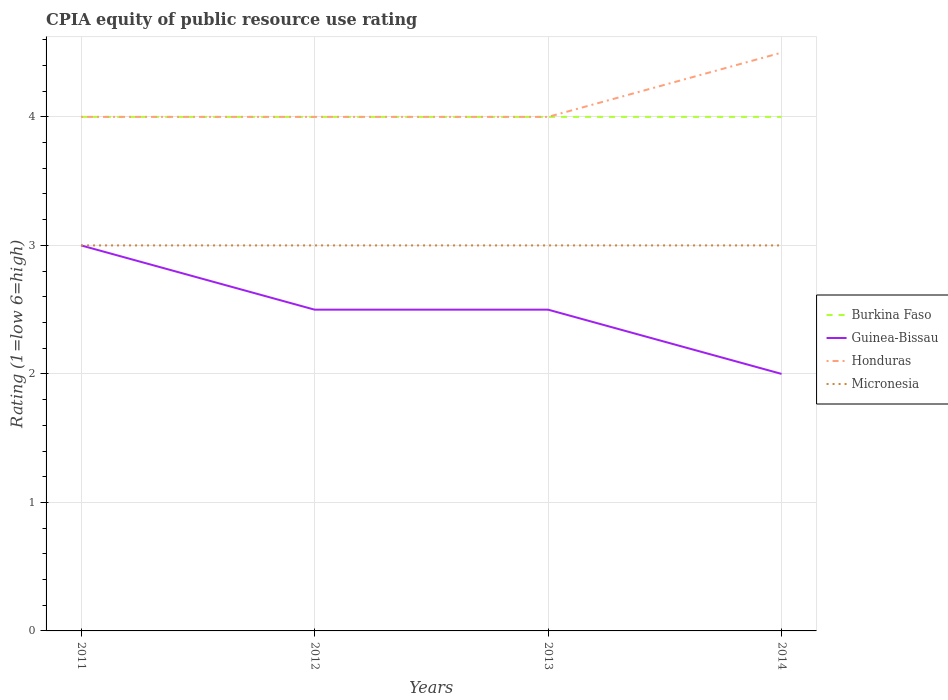How many different coloured lines are there?
Ensure brevity in your answer.  4. Does the line corresponding to Honduras intersect with the line corresponding to Guinea-Bissau?
Offer a very short reply. No. Across all years, what is the maximum CPIA rating in Honduras?
Keep it short and to the point. 4. What is the total CPIA rating in Micronesia in the graph?
Make the answer very short. 0. What is the difference between the highest and the second highest CPIA rating in Guinea-Bissau?
Ensure brevity in your answer.  1. What is the difference between the highest and the lowest CPIA rating in Honduras?
Your answer should be very brief. 1. How many lines are there?
Keep it short and to the point. 4. What is the difference between two consecutive major ticks on the Y-axis?
Your answer should be compact. 1. Does the graph contain any zero values?
Offer a terse response. No. Does the graph contain grids?
Your answer should be compact. Yes. Where does the legend appear in the graph?
Your answer should be very brief. Center right. What is the title of the graph?
Provide a short and direct response. CPIA equity of public resource use rating. Does "Netherlands" appear as one of the legend labels in the graph?
Give a very brief answer. No. What is the label or title of the X-axis?
Provide a succinct answer. Years. What is the label or title of the Y-axis?
Your answer should be very brief. Rating (1=low 6=high). What is the Rating (1=low 6=high) of Burkina Faso in 2011?
Offer a terse response. 4. What is the Rating (1=low 6=high) in Burkina Faso in 2012?
Provide a short and direct response. 4. What is the Rating (1=low 6=high) of Honduras in 2012?
Your answer should be compact. 4. What is the Rating (1=low 6=high) of Guinea-Bissau in 2013?
Ensure brevity in your answer.  2.5. What is the Rating (1=low 6=high) in Micronesia in 2013?
Give a very brief answer. 3. What is the Rating (1=low 6=high) of Guinea-Bissau in 2014?
Make the answer very short. 2. What is the Rating (1=low 6=high) in Honduras in 2014?
Keep it short and to the point. 4.5. Across all years, what is the minimum Rating (1=low 6=high) of Burkina Faso?
Offer a terse response. 4. What is the total Rating (1=low 6=high) of Burkina Faso in the graph?
Offer a terse response. 16. What is the difference between the Rating (1=low 6=high) in Burkina Faso in 2011 and that in 2012?
Your answer should be very brief. 0. What is the difference between the Rating (1=low 6=high) in Micronesia in 2011 and that in 2012?
Offer a very short reply. 0. What is the difference between the Rating (1=low 6=high) in Burkina Faso in 2011 and that in 2013?
Keep it short and to the point. 0. What is the difference between the Rating (1=low 6=high) of Guinea-Bissau in 2011 and that in 2013?
Offer a terse response. 0.5. What is the difference between the Rating (1=low 6=high) in Micronesia in 2011 and that in 2013?
Provide a short and direct response. 0. What is the difference between the Rating (1=low 6=high) of Burkina Faso in 2011 and that in 2014?
Offer a very short reply. 0. What is the difference between the Rating (1=low 6=high) in Honduras in 2011 and that in 2014?
Your answer should be very brief. -0.5. What is the difference between the Rating (1=low 6=high) in Burkina Faso in 2012 and that in 2013?
Offer a terse response. 0. What is the difference between the Rating (1=low 6=high) of Guinea-Bissau in 2012 and that in 2013?
Your answer should be compact. 0. What is the difference between the Rating (1=low 6=high) of Micronesia in 2012 and that in 2013?
Give a very brief answer. 0. What is the difference between the Rating (1=low 6=high) in Burkina Faso in 2012 and that in 2014?
Your response must be concise. 0. What is the difference between the Rating (1=low 6=high) of Honduras in 2012 and that in 2014?
Your response must be concise. -0.5. What is the difference between the Rating (1=low 6=high) in Micronesia in 2012 and that in 2014?
Your response must be concise. 0. What is the difference between the Rating (1=low 6=high) in Burkina Faso in 2011 and the Rating (1=low 6=high) in Honduras in 2012?
Offer a terse response. 0. What is the difference between the Rating (1=low 6=high) in Burkina Faso in 2011 and the Rating (1=low 6=high) in Micronesia in 2012?
Your response must be concise. 1. What is the difference between the Rating (1=low 6=high) in Guinea-Bissau in 2011 and the Rating (1=low 6=high) in Honduras in 2012?
Provide a short and direct response. -1. What is the difference between the Rating (1=low 6=high) in Guinea-Bissau in 2011 and the Rating (1=low 6=high) in Micronesia in 2012?
Make the answer very short. 0. What is the difference between the Rating (1=low 6=high) in Honduras in 2011 and the Rating (1=low 6=high) in Micronesia in 2012?
Your answer should be very brief. 1. What is the difference between the Rating (1=low 6=high) of Honduras in 2011 and the Rating (1=low 6=high) of Micronesia in 2013?
Give a very brief answer. 1. What is the difference between the Rating (1=low 6=high) in Burkina Faso in 2011 and the Rating (1=low 6=high) in Guinea-Bissau in 2014?
Keep it short and to the point. 2. What is the difference between the Rating (1=low 6=high) of Guinea-Bissau in 2011 and the Rating (1=low 6=high) of Micronesia in 2014?
Offer a terse response. 0. What is the difference between the Rating (1=low 6=high) of Honduras in 2011 and the Rating (1=low 6=high) of Micronesia in 2014?
Your answer should be compact. 1. What is the difference between the Rating (1=low 6=high) of Burkina Faso in 2012 and the Rating (1=low 6=high) of Guinea-Bissau in 2013?
Your answer should be very brief. 1.5. What is the difference between the Rating (1=low 6=high) in Burkina Faso in 2012 and the Rating (1=low 6=high) in Micronesia in 2013?
Your answer should be compact. 1. What is the difference between the Rating (1=low 6=high) of Guinea-Bissau in 2012 and the Rating (1=low 6=high) of Honduras in 2013?
Offer a very short reply. -1.5. What is the difference between the Rating (1=low 6=high) of Guinea-Bissau in 2012 and the Rating (1=low 6=high) of Micronesia in 2014?
Keep it short and to the point. -0.5. What is the difference between the Rating (1=low 6=high) of Honduras in 2012 and the Rating (1=low 6=high) of Micronesia in 2014?
Offer a very short reply. 1. What is the difference between the Rating (1=low 6=high) in Burkina Faso in 2013 and the Rating (1=low 6=high) in Honduras in 2014?
Provide a succinct answer. -0.5. What is the difference between the Rating (1=low 6=high) of Burkina Faso in 2013 and the Rating (1=low 6=high) of Micronesia in 2014?
Offer a terse response. 1. What is the difference between the Rating (1=low 6=high) in Guinea-Bissau in 2013 and the Rating (1=low 6=high) in Micronesia in 2014?
Ensure brevity in your answer.  -0.5. What is the difference between the Rating (1=low 6=high) of Honduras in 2013 and the Rating (1=low 6=high) of Micronesia in 2014?
Offer a very short reply. 1. What is the average Rating (1=low 6=high) of Honduras per year?
Offer a very short reply. 4.12. In the year 2011, what is the difference between the Rating (1=low 6=high) in Burkina Faso and Rating (1=low 6=high) in Guinea-Bissau?
Ensure brevity in your answer.  1. In the year 2011, what is the difference between the Rating (1=low 6=high) in Burkina Faso and Rating (1=low 6=high) in Micronesia?
Your answer should be very brief. 1. In the year 2011, what is the difference between the Rating (1=low 6=high) of Guinea-Bissau and Rating (1=low 6=high) of Honduras?
Give a very brief answer. -1. In the year 2011, what is the difference between the Rating (1=low 6=high) in Guinea-Bissau and Rating (1=low 6=high) in Micronesia?
Give a very brief answer. 0. In the year 2011, what is the difference between the Rating (1=low 6=high) of Honduras and Rating (1=low 6=high) of Micronesia?
Offer a very short reply. 1. In the year 2012, what is the difference between the Rating (1=low 6=high) of Burkina Faso and Rating (1=low 6=high) of Guinea-Bissau?
Offer a terse response. 1.5. In the year 2012, what is the difference between the Rating (1=low 6=high) of Burkina Faso and Rating (1=low 6=high) of Honduras?
Your answer should be compact. 0. In the year 2012, what is the difference between the Rating (1=low 6=high) of Burkina Faso and Rating (1=low 6=high) of Micronesia?
Make the answer very short. 1. In the year 2012, what is the difference between the Rating (1=low 6=high) of Guinea-Bissau and Rating (1=low 6=high) of Honduras?
Provide a succinct answer. -1.5. In the year 2012, what is the difference between the Rating (1=low 6=high) of Honduras and Rating (1=low 6=high) of Micronesia?
Keep it short and to the point. 1. In the year 2013, what is the difference between the Rating (1=low 6=high) in Burkina Faso and Rating (1=low 6=high) in Micronesia?
Give a very brief answer. 1. In the year 2013, what is the difference between the Rating (1=low 6=high) in Guinea-Bissau and Rating (1=low 6=high) in Honduras?
Offer a very short reply. -1.5. In the year 2013, what is the difference between the Rating (1=low 6=high) of Honduras and Rating (1=low 6=high) of Micronesia?
Make the answer very short. 1. In the year 2014, what is the difference between the Rating (1=low 6=high) in Burkina Faso and Rating (1=low 6=high) in Micronesia?
Make the answer very short. 1. In the year 2014, what is the difference between the Rating (1=low 6=high) of Honduras and Rating (1=low 6=high) of Micronesia?
Offer a very short reply. 1.5. What is the ratio of the Rating (1=low 6=high) in Guinea-Bissau in 2011 to that in 2012?
Ensure brevity in your answer.  1.2. What is the ratio of the Rating (1=low 6=high) in Micronesia in 2011 to that in 2012?
Your answer should be very brief. 1. What is the ratio of the Rating (1=low 6=high) of Guinea-Bissau in 2011 to that in 2013?
Give a very brief answer. 1.2. What is the ratio of the Rating (1=low 6=high) in Honduras in 2011 to that in 2013?
Give a very brief answer. 1. What is the ratio of the Rating (1=low 6=high) in Micronesia in 2011 to that in 2013?
Offer a terse response. 1. What is the ratio of the Rating (1=low 6=high) of Burkina Faso in 2011 to that in 2014?
Your response must be concise. 1. What is the ratio of the Rating (1=low 6=high) in Micronesia in 2011 to that in 2014?
Keep it short and to the point. 1. What is the ratio of the Rating (1=low 6=high) in Burkina Faso in 2012 to that in 2013?
Provide a short and direct response. 1. What is the ratio of the Rating (1=low 6=high) of Guinea-Bissau in 2012 to that in 2013?
Your answer should be compact. 1. What is the ratio of the Rating (1=low 6=high) of Honduras in 2012 to that in 2013?
Your answer should be compact. 1. What is the ratio of the Rating (1=low 6=high) in Burkina Faso in 2012 to that in 2014?
Your answer should be very brief. 1. What is the ratio of the Rating (1=low 6=high) in Honduras in 2013 to that in 2014?
Offer a very short reply. 0.89. What is the ratio of the Rating (1=low 6=high) in Micronesia in 2013 to that in 2014?
Offer a very short reply. 1. What is the difference between the highest and the second highest Rating (1=low 6=high) of Guinea-Bissau?
Make the answer very short. 0.5. What is the difference between the highest and the lowest Rating (1=low 6=high) of Micronesia?
Your answer should be very brief. 0. 